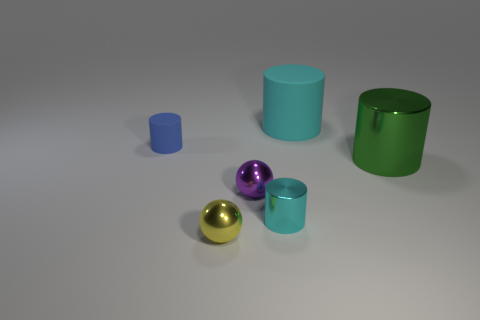Add 1 big yellow cubes. How many objects exist? 7 Subtract all cylinders. How many objects are left? 2 Subtract 0 purple cubes. How many objects are left? 6 Subtract all blocks. Subtract all big green shiny things. How many objects are left? 5 Add 2 big cylinders. How many big cylinders are left? 4 Add 6 cyan matte spheres. How many cyan matte spheres exist? 6 